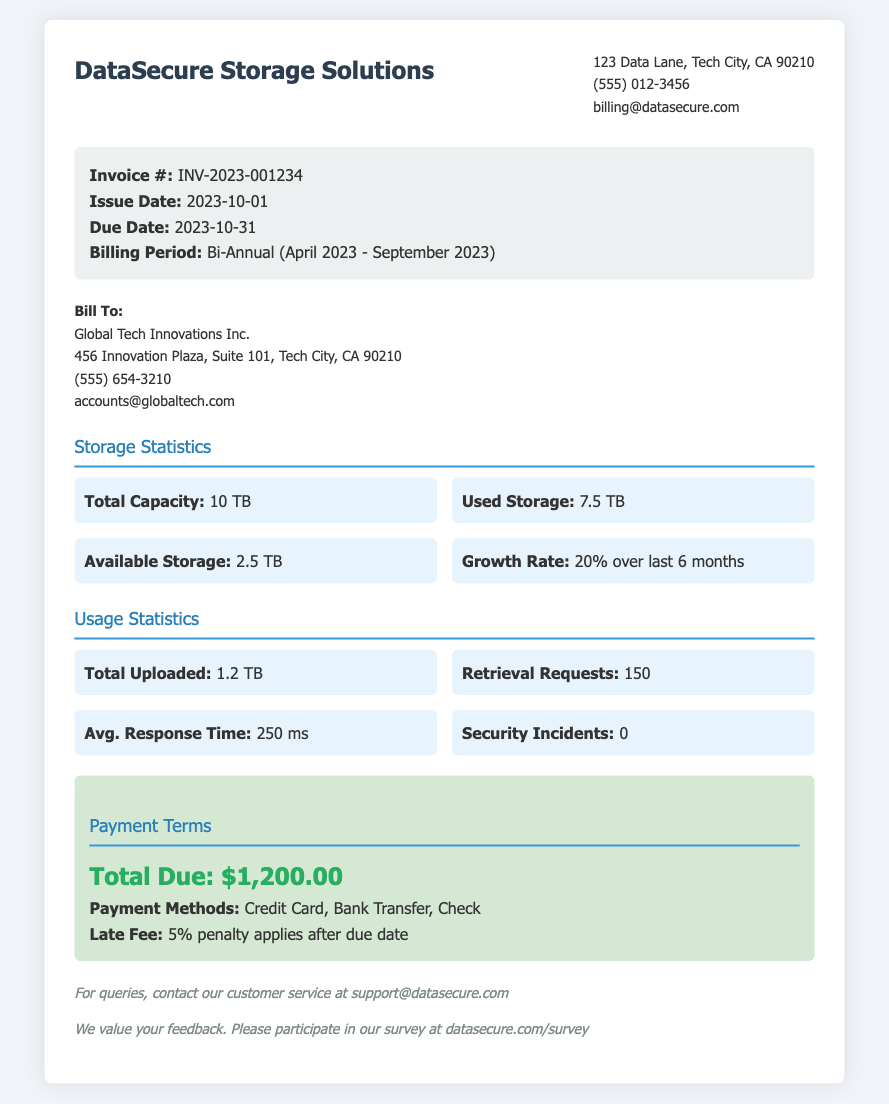What is the invoice number? The invoice number is listed prominently at the top of the invoice details section.
Answer: INV-2023-001234 What is the total capacity of the storage? Total capacity of the storage is mentioned in the storage statistics section.
Answer: 10 TB What is the average response time for retrieval requests? The average response time is noted in the usage statistics section as an important performance metric.
Answer: 250 ms What is the due date for payment? The due date is specified in the invoice details section under payment deadlines.
Answer: 2023-10-31 What penalty applies after the due date? The invoice specifies the penalty for late payment in the payment terms section.
Answer: 5% penalty How much storage is currently used? The used storage is provided in the storage statistics section to show current usage status.
Answer: 7.5 TB What is the growth rate of storage usage over the last six months? The growth rate indicates how much the storage usage has increased over time.
Answer: 20% over last 6 months What company is billed in this invoice? The company information section identifies who the invoice is addressed to.
Answer: Global Tech Innovations Inc 